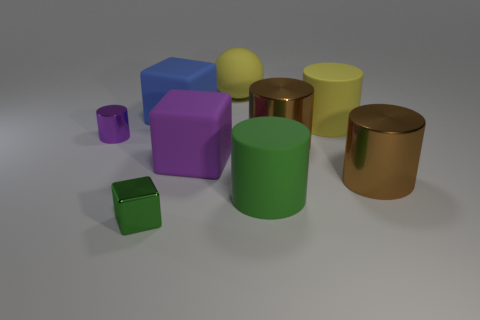Subtract all big yellow rubber cylinders. How many cylinders are left? 4 Subtract all yellow cylinders. How many cylinders are left? 4 Subtract all red cylinders. Subtract all purple cubes. How many cylinders are left? 5 Subtract all spheres. How many objects are left? 8 Add 9 tiny purple metallic things. How many tiny purple metallic things exist? 10 Subtract 0 purple balls. How many objects are left? 9 Subtract all yellow matte cylinders. Subtract all yellow objects. How many objects are left? 6 Add 6 big yellow objects. How many big yellow objects are left? 8 